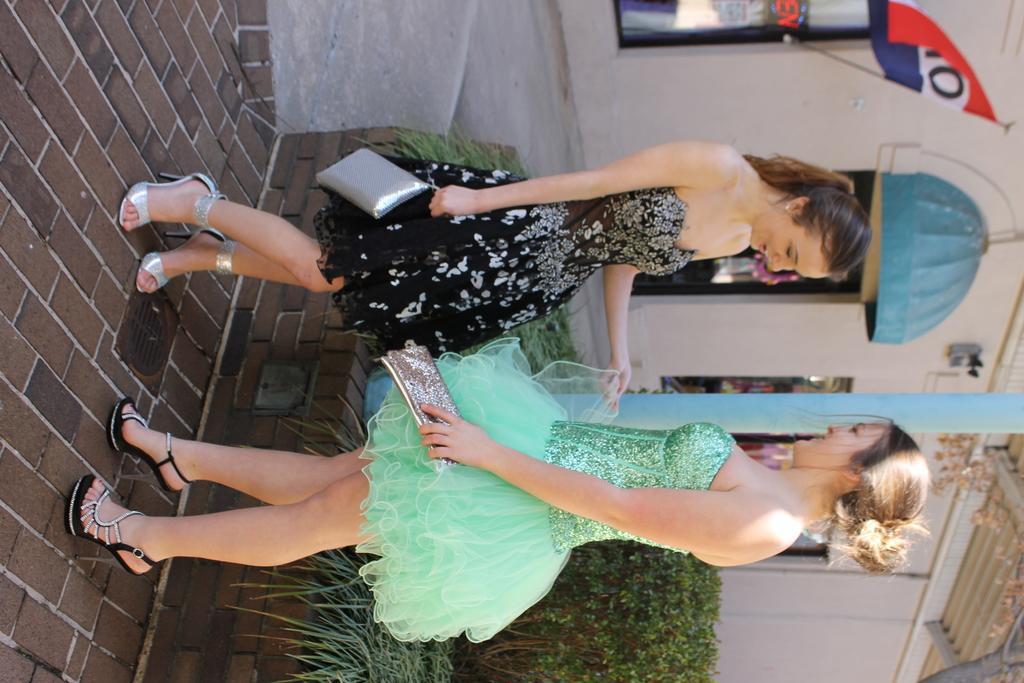Can you describe this image briefly? In the center of the image we can see two ladies standing and holding wallets. At the bottom there are bushes. In the background there is a building and a flag. 